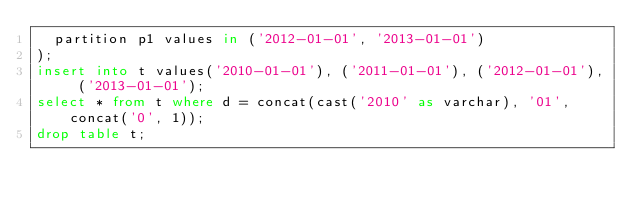<code> <loc_0><loc_0><loc_500><loc_500><_SQL_>	partition p1 values in ('2012-01-01', '2013-01-01')
);
insert into t values('2010-01-01'), ('2011-01-01'), ('2012-01-01'), ('2013-01-01');
select * from t where d = concat(cast('2010' as varchar), '01', concat('0', 1));
drop table t;</code> 